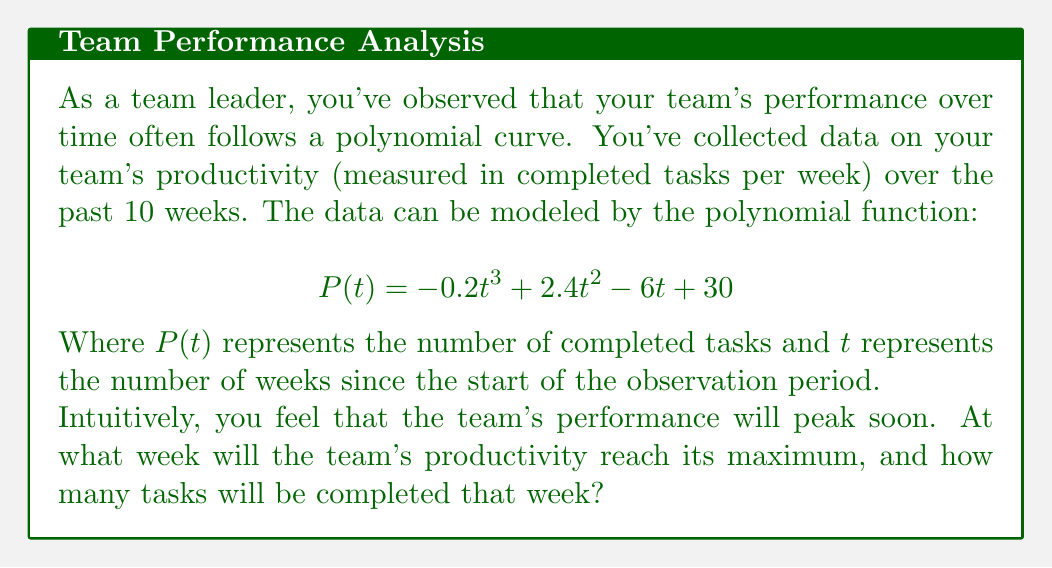Can you answer this question? To solve this problem, we need to follow these steps:

1) First, we need to find the derivative of the function $P(t)$. This will give us the rate of change of productivity with respect to time.

   $$ P'(t) = -0.6t^2 + 4.8t - 6 $$

2) To find the maximum point, we need to find where the derivative equals zero. This is because at the peak, the rate of change will be zero.

   $$ -0.6t^2 + 4.8t - 6 = 0 $$

3) This is a quadratic equation. We can solve it using the quadratic formula:

   $$ t = \frac{-b \pm \sqrt{b^2 - 4ac}}{2a} $$

   Where $a = -0.6$, $b = 4.8$, and $c = -6$

4) Plugging in these values:

   $$ t = \frac{-4.8 \pm \sqrt{4.8^2 - 4(-0.6)(-6)}}{2(-0.6)} $$
   $$ = \frac{-4.8 \pm \sqrt{23.04 - 14.4}}{-1.2} $$
   $$ = \frac{-4.8 \pm \sqrt{8.64}}{-1.2} $$
   $$ = \frac{-4.8 \pm 2.94}{-1.2} $$

5) This gives us two solutions:
   $t = 6.45$ or $t = 1.55$

6) Since we're looking for a maximum, and the coefficient of $t^3$ in the original function is negative (indicating the function eventually decreases), we choose the larger value: $t = 6.45$

7) Since we're dealing with weeks, we round this to the nearest whole number: 6 weeks.

8) To find the number of tasks completed at this peak, we plug $t = 6$ back into our original function:

   $$ P(6) = -0.2(6)^3 + 2.4(6)^2 - 6(6) + 30 $$
   $$ = -43.2 + 86.4 - 36 + 30 $$
   $$ = 37.2 $$

9) Rounding to the nearest whole number of tasks, we get 37 tasks.
Answer: The team's productivity will reach its maximum at week 6, completing approximately 37 tasks. 